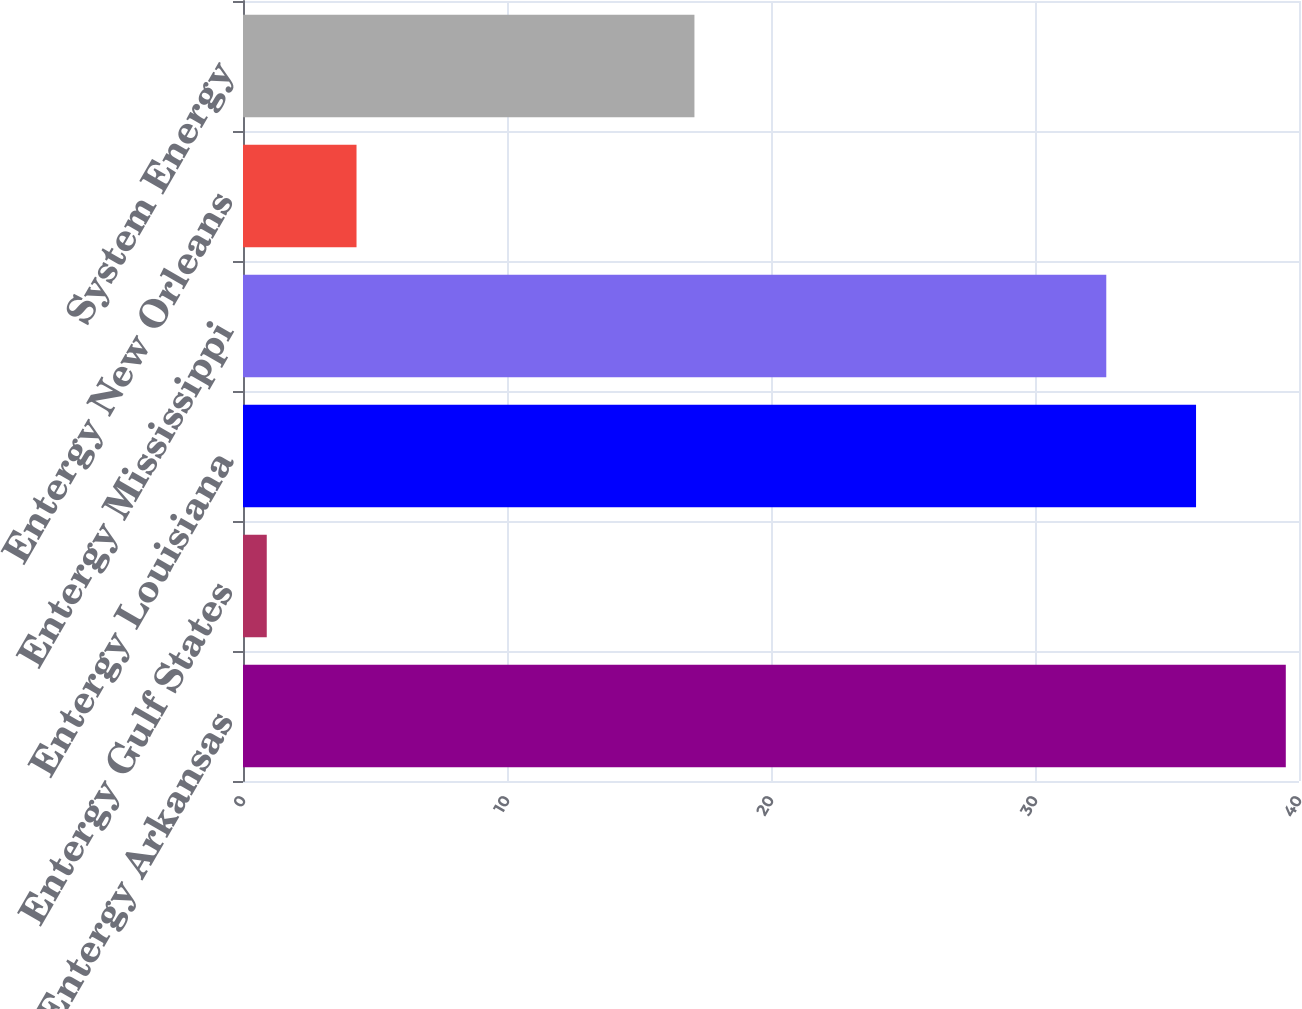<chart> <loc_0><loc_0><loc_500><loc_500><bar_chart><fcel>Entergy Arkansas<fcel>Entergy Gulf States<fcel>Entergy Louisiana<fcel>Entergy Mississippi<fcel>Entergy New Orleans<fcel>System Energy<nl><fcel>39.5<fcel>0.9<fcel>36.1<fcel>32.7<fcel>4.3<fcel>17.1<nl></chart> 